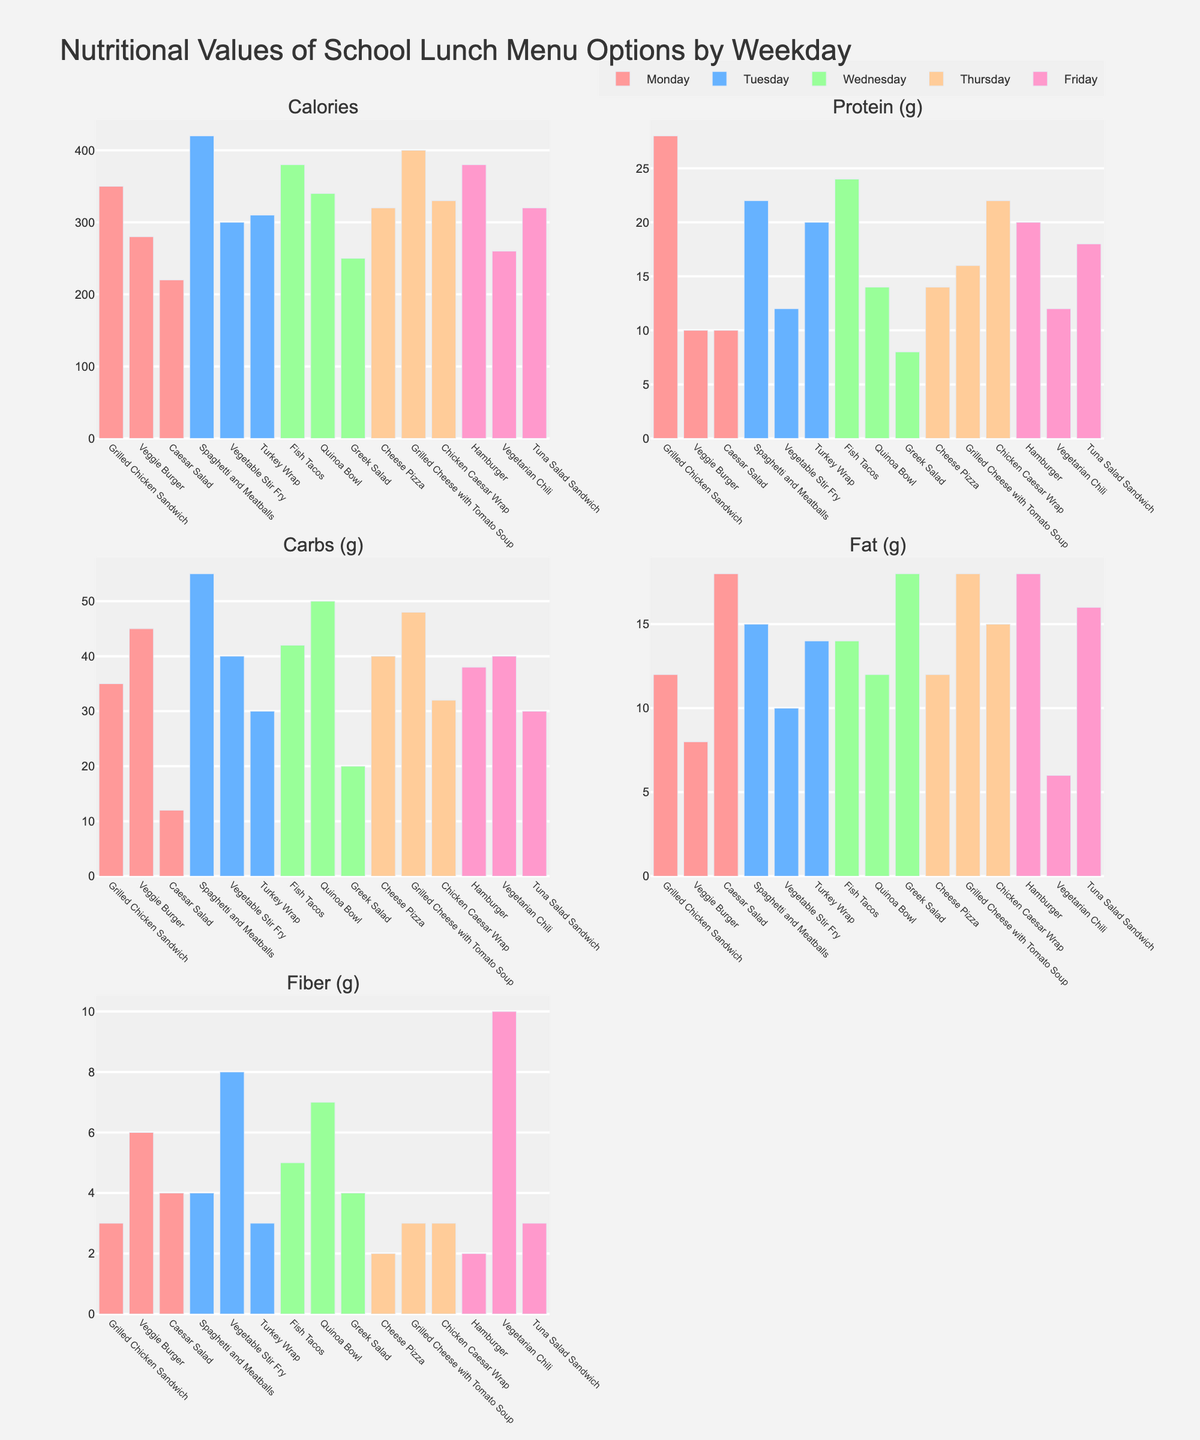Which day has the highest protein (g) in its menu items? Look for the highest bar in the subplots for 'Protein (g)' and note the corresponding day. The highest protein content is found in 'Fish Tacos' on Wednesday.
Answer: Wednesday What is the total number of calories for all menu items on Friday? Add up the 'Calories' values for each menu item on Friday: Hamburger (380), Vegetarian Chili (260), Tuna Salad Sandwich (320) = 380 + 260 + 320.
Answer: 960 Which menu item has the lowest fiber content, and what is its value? Look for the shortest bar in the subplots for 'Fiber (g)' and note the corresponding menu item and its value. 'Cheese Pizza' on Thursday has the lowest fiber content with a value of 2g.
Answer: Cheese Pizza, 2g Between 'Grilled Chicken Sandwich' and 'Veggie Burger', which has higher fat content? Compare the 'Fat (g)' bars of 'Grilled Chicken Sandwich' and 'Veggie Burger' in the 'Fat (g)' subplot. 'Grilled Chicken Sandwich' has 12g and 'Veggie Burger' has 8g.
Answer: Grilled Chicken Sandwich Which day has the most diverse range of carbohydrate values across its menu items? Determine the range by calculating the difference between the highest and lowest 'Carbs (g)' values for each day. The larger the range, the more diverse. Wednesday ranges from 20 (Greek Salad) to 50 (Quinoa Bowl), a range of 30, which is the largest.
Answer: Wednesday What is the average fiber content in the menu items on Tuesday? Add up the 'Fiber (g)' values for each menu item on Tuesday and divide by the number of items: Vegetable Stir Fry (8), Spaghetti and Meatballs (4), Turkey Wrap (3). Average = (8 + 4 + 3) / 3.
Answer: 5 g How many menu items exceed 300 calories? Check all the 'Calories' bars to count how many exceed the 300 mark: Grilled Chicken Sandwich (350), Spaghetti and Meatballs (420), Turkey Wrap (310), Fish Tacos (380), Quinoa Bowl (340), Cheese Pizza (320), Grilled Cheese with Tomato Soup (400), Chicken Caesar Wrap (330), Hamburger (380), Tuna Salad Sandwich (320).
Answer: 10 Which menu item contains the highest amount of fiber and on what day is it served? Find the highest bar in any of the 'Fiber (g)' subplots. 'Vegetarian Chili' on Friday has the highest fiber content at 10g.
Answer: Vegetarian Chili on Friday Which day on average has the highest calories in its menu items? Calculate the average calories for each day by summing the 'Calories' values and dividing by the number of menu items. Monday: (350 + 280 + 220) / 3, Tuesday: (420 + 300 + 310) / 3, Wednesday: (380 + 340 + 250) / 3, Thursday: (320 + 400 + 330) / 3, Friday: (380 + 260 + 320) / 3. Compare the averages. Tuesday has the highest average with (420 + 300 + 310) / 3 = 343.3 calories.
Answer: Tuesday 